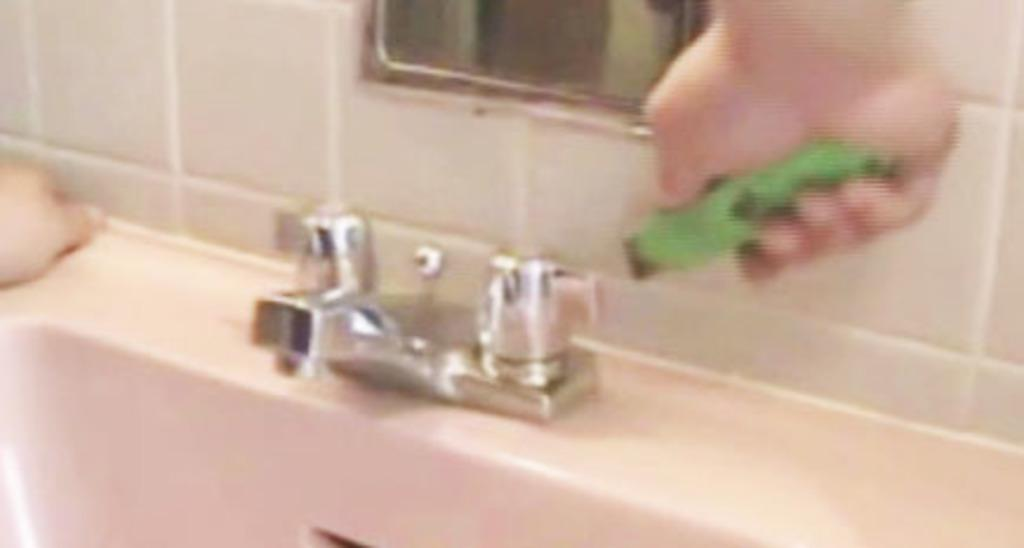What type of flooring is visible in the image? There are tiles in the image. What part of a person can be seen in the image? A human hand is visible in the image. What is used for reflecting images in the image? There is a mirror in the image. What is used for washing hands in the image? There is a sink in the image. What is used to control the flow of water in the image? A tap is present in the image. How many dogs are sitting on the chairs in the image? There are no dogs or chairs present in the image. What color is the orange in the image? There is no orange present in the image. 